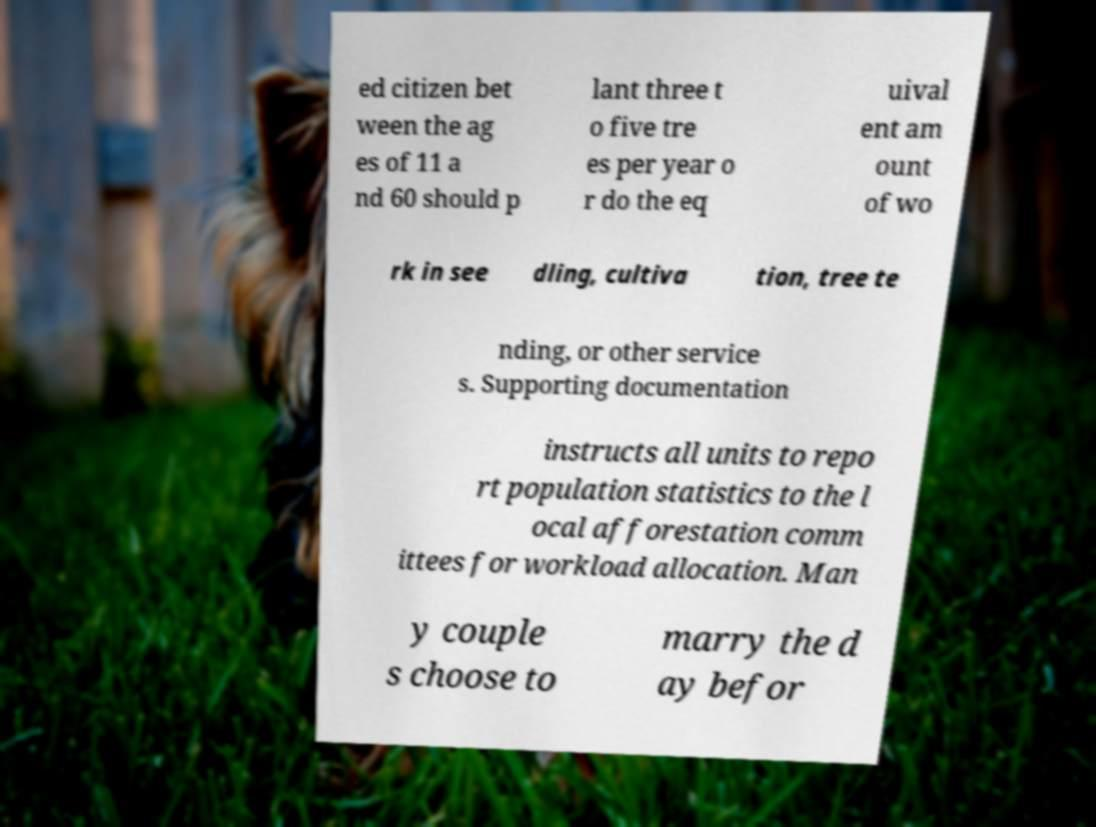Please read and relay the text visible in this image. What does it say? ed citizen bet ween the ag es of 11 a nd 60 should p lant three t o five tre es per year o r do the eq uival ent am ount of wo rk in see dling, cultiva tion, tree te nding, or other service s. Supporting documentation instructs all units to repo rt population statistics to the l ocal afforestation comm ittees for workload allocation. Man y couple s choose to marry the d ay befor 